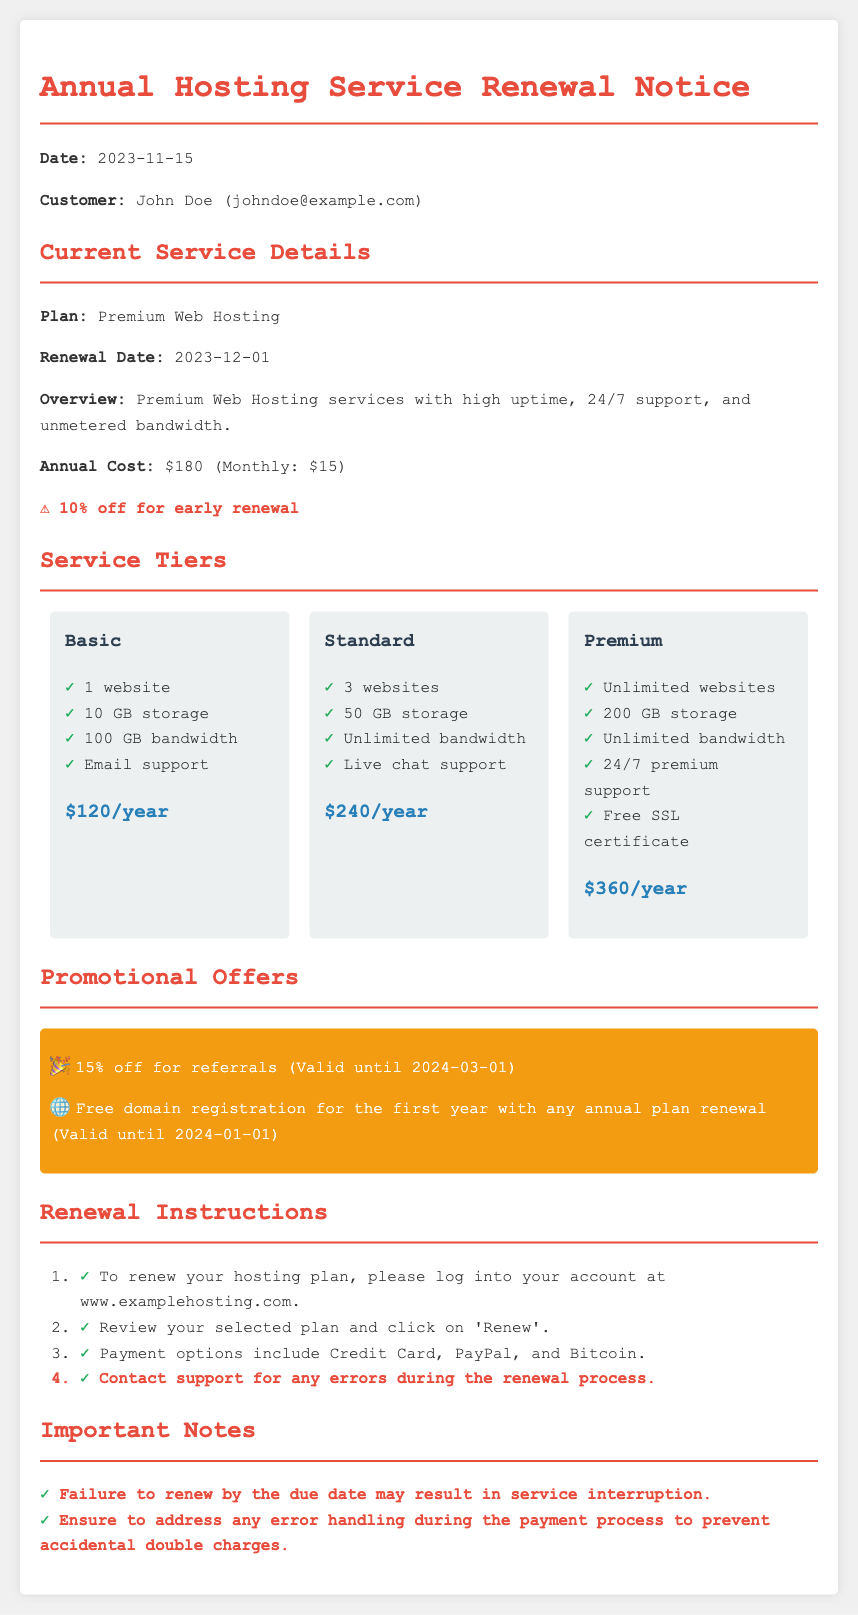what is the current plan? The current plan mentioned in the document is "Premium Web Hosting."
Answer: Premium Web Hosting when is the renewal date? The renewal date specified in the document is "2023-12-01."
Answer: 2023-12-01 how much is the annual cost of the Premium plan? The annual cost for the Premium plan is stated in the document, which is "$180."
Answer: $180 what discount is available for early renewal? The discount for early renewal mentioned in the document is "10% off."
Answer: 10% off what is included in the Premium service tier? The Premium service tier includes several items, specifically "Unlimited websites, 200 GB storage, Unlimited bandwidth, 24/7 premium support, Free SSL certificate."
Answer: Unlimited websites, 200 GB storage, Unlimited bandwidth, 24/7 premium support, Free SSL certificate how much discount is offered for referrals? The document indicates a referral discount of "15% off."
Answer: 15% off what is a potential consequence of failing to renew by the due date? The document states that failure to renew by the due date may result in "service interruption."
Answer: service interruption what payment options are provided for renewing the service? The document lists the payment options as "Credit Card, PayPal, and Bitcoin."
Answer: Credit Card, PayPal, and Bitcoin what promotional offer is valid until 2024-01-01? The document mentions that "Free domain registration for the first year with any annual plan renewal" is valid until this date.
Answer: Free domain registration for the first year with any annual plan renewal 